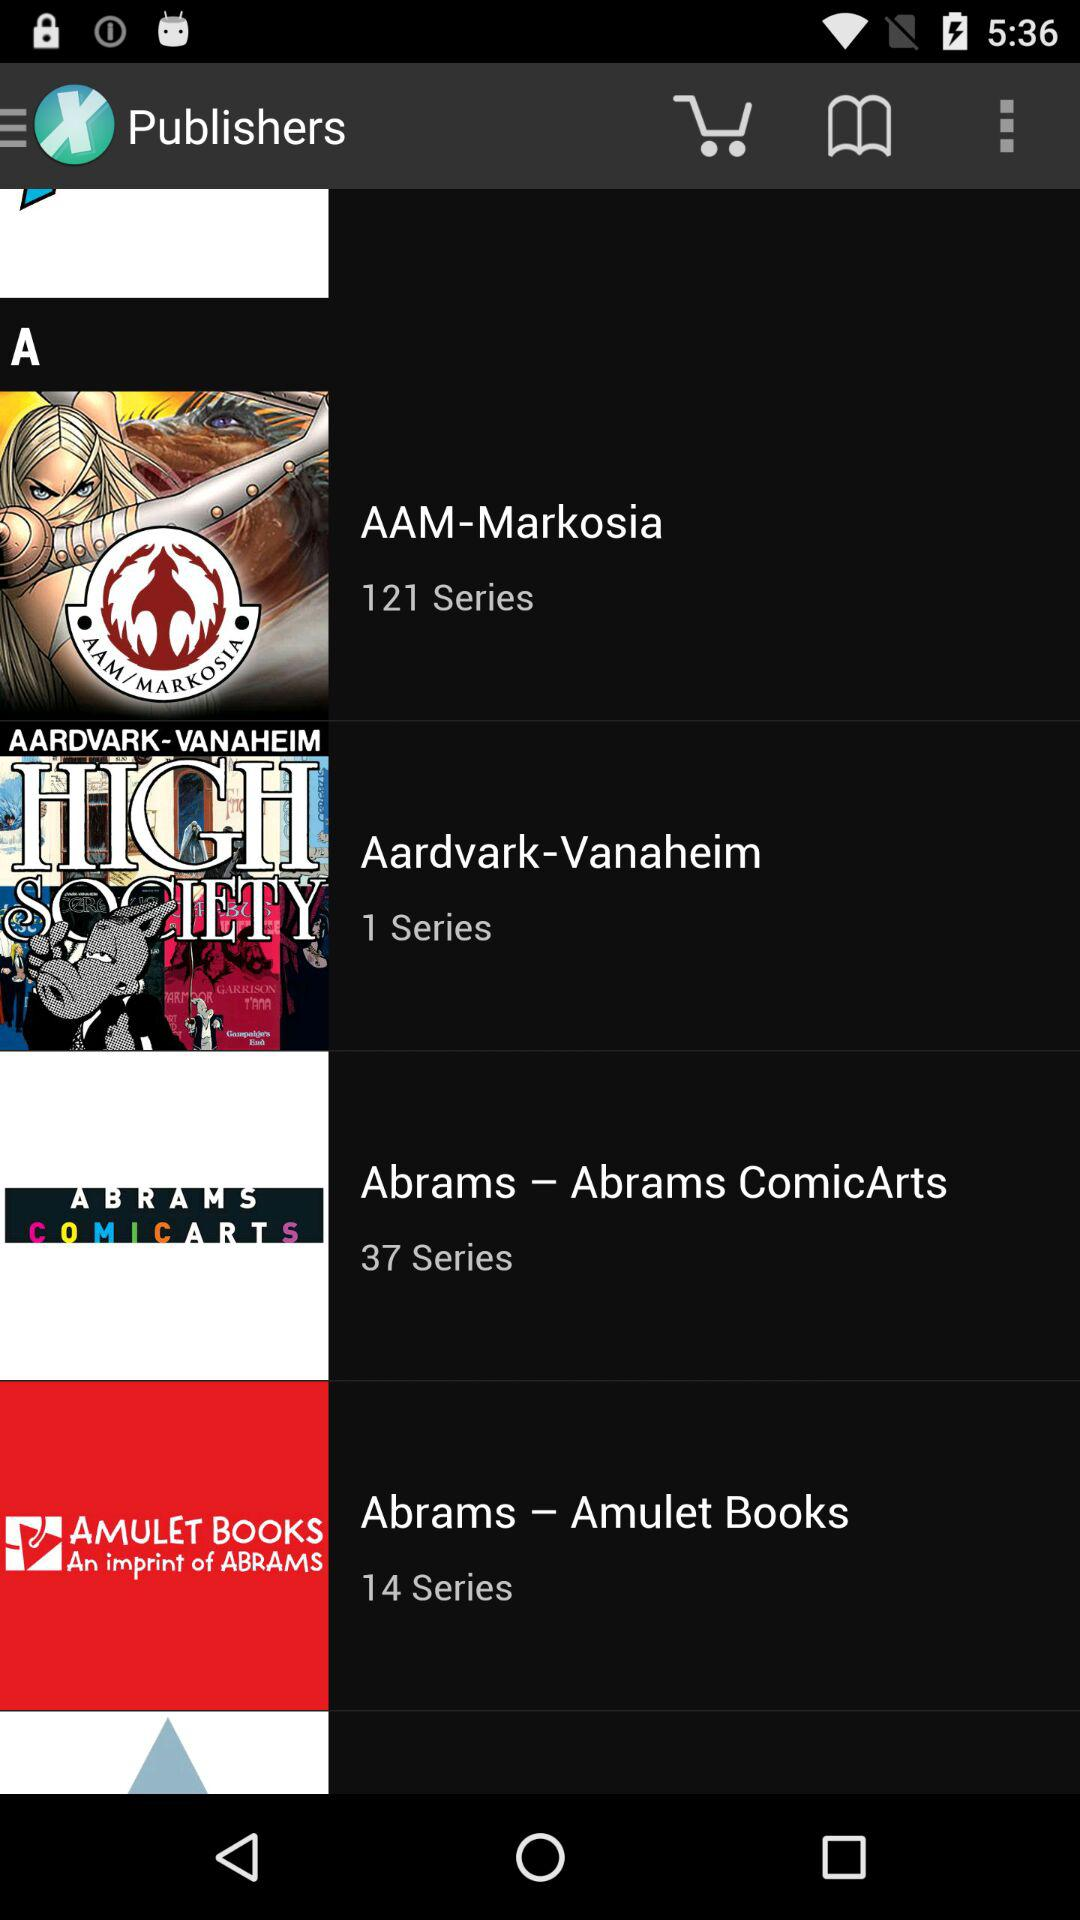What is the name of the application? The name of the application is "Publishers". 